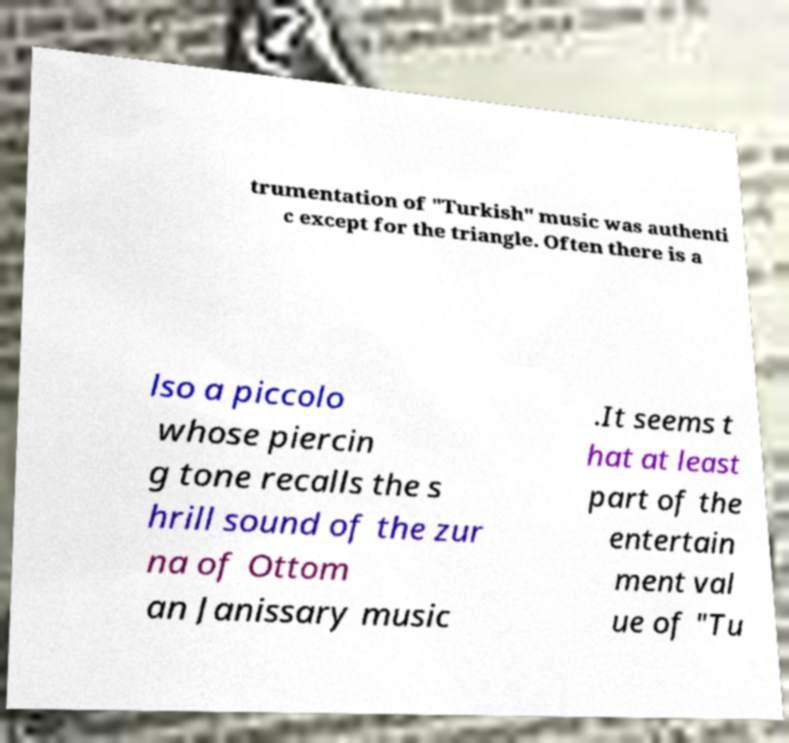Can you read and provide the text displayed in the image?This photo seems to have some interesting text. Can you extract and type it out for me? trumentation of "Turkish" music was authenti c except for the triangle. Often there is a lso a piccolo whose piercin g tone recalls the s hrill sound of the zur na of Ottom an Janissary music .It seems t hat at least part of the entertain ment val ue of "Tu 